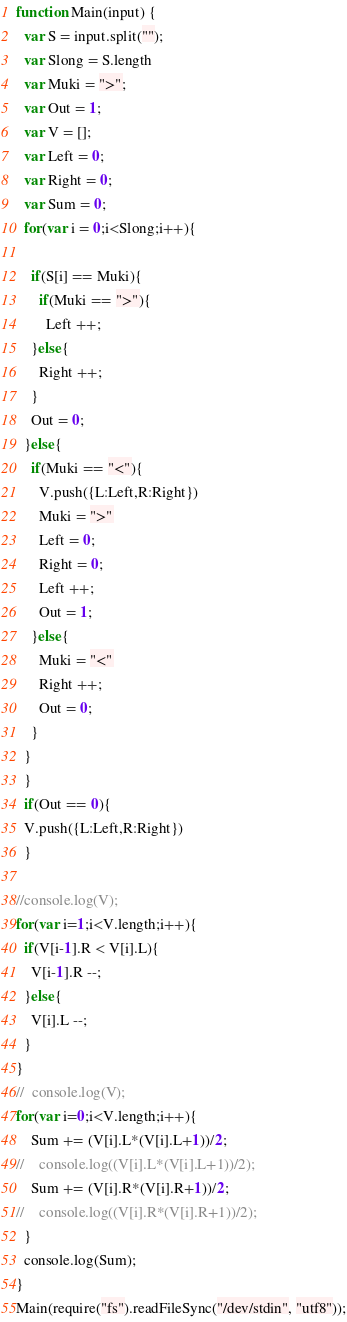Convert code to text. <code><loc_0><loc_0><loc_500><loc_500><_JavaScript_>function Main(input) {
  var S = input.split("");
  var Slong = S.length
  var Muki = ">";
  var Out = 1;
  var V = [];
  var Left = 0;
  var Right = 0;
  var Sum = 0;
  for(var i = 0;i<Slong;i++){

    if(S[i] == Muki){
      if(Muki == ">"){
        Left ++;
    }else{
      Right ++;
    }
    Out = 0;
  }else{
    if(Muki == "<"){
      V.push({L:Left,R:Right})
      Muki = ">"
      Left = 0;
      Right = 0;
      Left ++;
      Out = 1;
    }else{
      Muki = "<"
      Right ++;
      Out = 0;
    }
  }
  }
  if(Out == 0){
  V.push({L:Left,R:Right})
  }
  
//console.log(V);
for(var i=1;i<V.length;i++){
  if(V[i-1].R < V[i].L){
    V[i-1].R --; 
  }else{
    V[i].L --;
  }
}
//  console.log(V);
for(var i=0;i<V.length;i++){
    Sum += (V[i].L*(V[i].L+1))/2;
//    console.log((V[i].L*(V[i].L+1))/2);
    Sum += (V[i].R*(V[i].R+1))/2;
//    console.log((V[i].R*(V[i].R+1))/2);
  }
  console.log(Sum);
}
Main(require("fs").readFileSync("/dev/stdin", "utf8"));</code> 